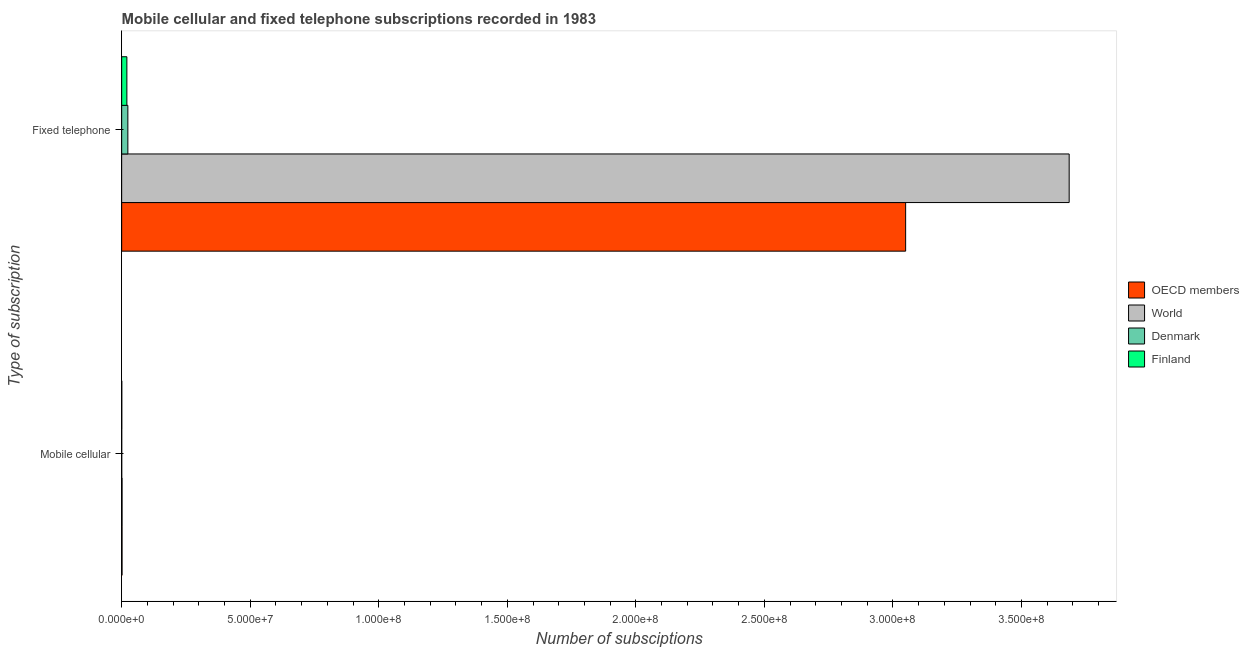What is the label of the 1st group of bars from the top?
Your answer should be very brief. Fixed telephone. What is the number of mobile cellular subscriptions in World?
Offer a very short reply. 1.49e+05. Across all countries, what is the maximum number of mobile cellular subscriptions?
Your answer should be compact. 1.49e+05. Across all countries, what is the minimum number of fixed telephone subscriptions?
Offer a very short reply. 2.02e+06. In which country was the number of mobile cellular subscriptions minimum?
Provide a succinct answer. Denmark. What is the total number of mobile cellular subscriptions in the graph?
Give a very brief answer. 3.52e+05. What is the difference between the number of fixed telephone subscriptions in OECD members and that in World?
Ensure brevity in your answer.  -6.36e+07. What is the difference between the number of fixed telephone subscriptions in World and the number of mobile cellular subscriptions in Finland?
Ensure brevity in your answer.  3.69e+08. What is the average number of mobile cellular subscriptions per country?
Your response must be concise. 8.81e+04. What is the difference between the number of mobile cellular subscriptions and number of fixed telephone subscriptions in Finland?
Provide a short and direct response. -1.98e+06. What is the ratio of the number of fixed telephone subscriptions in Denmark to that in OECD members?
Your answer should be compact. 0.01. What does the 1st bar from the top in Fixed telephone represents?
Keep it short and to the point. Finland. What does the 4th bar from the bottom in Mobile cellular represents?
Your response must be concise. Finland. Are all the bars in the graph horizontal?
Give a very brief answer. Yes. How many countries are there in the graph?
Offer a very short reply. 4. Does the graph contain any zero values?
Your response must be concise. No. Where does the legend appear in the graph?
Give a very brief answer. Center right. How are the legend labels stacked?
Ensure brevity in your answer.  Vertical. What is the title of the graph?
Provide a succinct answer. Mobile cellular and fixed telephone subscriptions recorded in 1983. What is the label or title of the X-axis?
Your answer should be very brief. Number of subsciptions. What is the label or title of the Y-axis?
Give a very brief answer. Type of subscription. What is the Number of subsciptions of OECD members in Mobile cellular?
Ensure brevity in your answer.  1.45e+05. What is the Number of subsciptions in World in Mobile cellular?
Offer a very short reply. 1.49e+05. What is the Number of subsciptions of Denmark in Mobile cellular?
Your response must be concise. 1.61e+04. What is the Number of subsciptions of Finland in Mobile cellular?
Offer a very short reply. 4.22e+04. What is the Number of subsciptions in OECD members in Fixed telephone?
Ensure brevity in your answer.  3.05e+08. What is the Number of subsciptions of World in Fixed telephone?
Ensure brevity in your answer.  3.69e+08. What is the Number of subsciptions of Denmark in Fixed telephone?
Your response must be concise. 2.40e+06. What is the Number of subsciptions in Finland in Fixed telephone?
Offer a terse response. 2.02e+06. Across all Type of subscription, what is the maximum Number of subsciptions of OECD members?
Ensure brevity in your answer.  3.05e+08. Across all Type of subscription, what is the maximum Number of subsciptions in World?
Ensure brevity in your answer.  3.69e+08. Across all Type of subscription, what is the maximum Number of subsciptions in Denmark?
Keep it short and to the point. 2.40e+06. Across all Type of subscription, what is the maximum Number of subsciptions in Finland?
Offer a very short reply. 2.02e+06. Across all Type of subscription, what is the minimum Number of subsciptions of OECD members?
Offer a terse response. 1.45e+05. Across all Type of subscription, what is the minimum Number of subsciptions in World?
Your response must be concise. 1.49e+05. Across all Type of subscription, what is the minimum Number of subsciptions of Denmark?
Ensure brevity in your answer.  1.61e+04. Across all Type of subscription, what is the minimum Number of subsciptions of Finland?
Your answer should be compact. 4.22e+04. What is the total Number of subsciptions of OECD members in the graph?
Your response must be concise. 3.05e+08. What is the total Number of subsciptions in World in the graph?
Your response must be concise. 3.69e+08. What is the total Number of subsciptions of Denmark in the graph?
Ensure brevity in your answer.  2.42e+06. What is the total Number of subsciptions in Finland in the graph?
Your answer should be very brief. 2.06e+06. What is the difference between the Number of subsciptions of OECD members in Mobile cellular and that in Fixed telephone?
Offer a very short reply. -3.05e+08. What is the difference between the Number of subsciptions of World in Mobile cellular and that in Fixed telephone?
Offer a terse response. -3.68e+08. What is the difference between the Number of subsciptions of Denmark in Mobile cellular and that in Fixed telephone?
Your response must be concise. -2.39e+06. What is the difference between the Number of subsciptions of Finland in Mobile cellular and that in Fixed telephone?
Your answer should be very brief. -1.98e+06. What is the difference between the Number of subsciptions of OECD members in Mobile cellular and the Number of subsciptions of World in Fixed telephone?
Provide a short and direct response. -3.68e+08. What is the difference between the Number of subsciptions in OECD members in Mobile cellular and the Number of subsciptions in Denmark in Fixed telephone?
Offer a very short reply. -2.26e+06. What is the difference between the Number of subsciptions in OECD members in Mobile cellular and the Number of subsciptions in Finland in Fixed telephone?
Give a very brief answer. -1.88e+06. What is the difference between the Number of subsciptions of World in Mobile cellular and the Number of subsciptions of Denmark in Fixed telephone?
Give a very brief answer. -2.25e+06. What is the difference between the Number of subsciptions of World in Mobile cellular and the Number of subsciptions of Finland in Fixed telephone?
Make the answer very short. -1.87e+06. What is the difference between the Number of subsciptions in Denmark in Mobile cellular and the Number of subsciptions in Finland in Fixed telephone?
Keep it short and to the point. -2.00e+06. What is the average Number of subsciptions in OECD members per Type of subscription?
Provide a short and direct response. 1.53e+08. What is the average Number of subsciptions in World per Type of subscription?
Provide a succinct answer. 1.84e+08. What is the average Number of subsciptions of Denmark per Type of subscription?
Make the answer very short. 1.21e+06. What is the average Number of subsciptions in Finland per Type of subscription?
Your answer should be compact. 1.03e+06. What is the difference between the Number of subsciptions of OECD members and Number of subsciptions of World in Mobile cellular?
Your answer should be compact. -3564. What is the difference between the Number of subsciptions of OECD members and Number of subsciptions of Denmark in Mobile cellular?
Offer a terse response. 1.29e+05. What is the difference between the Number of subsciptions in OECD members and Number of subsciptions in Finland in Mobile cellular?
Your answer should be compact. 1.03e+05. What is the difference between the Number of subsciptions in World and Number of subsciptions in Denmark in Mobile cellular?
Offer a terse response. 1.33e+05. What is the difference between the Number of subsciptions in World and Number of subsciptions in Finland in Mobile cellular?
Provide a short and direct response. 1.07e+05. What is the difference between the Number of subsciptions in Denmark and Number of subsciptions in Finland in Mobile cellular?
Offer a terse response. -2.61e+04. What is the difference between the Number of subsciptions in OECD members and Number of subsciptions in World in Fixed telephone?
Offer a very short reply. -6.36e+07. What is the difference between the Number of subsciptions of OECD members and Number of subsciptions of Denmark in Fixed telephone?
Keep it short and to the point. 3.03e+08. What is the difference between the Number of subsciptions in OECD members and Number of subsciptions in Finland in Fixed telephone?
Keep it short and to the point. 3.03e+08. What is the difference between the Number of subsciptions in World and Number of subsciptions in Denmark in Fixed telephone?
Offer a very short reply. 3.66e+08. What is the difference between the Number of subsciptions of World and Number of subsciptions of Finland in Fixed telephone?
Ensure brevity in your answer.  3.67e+08. What is the difference between the Number of subsciptions of Denmark and Number of subsciptions of Finland in Fixed telephone?
Give a very brief answer. 3.82e+05. What is the ratio of the Number of subsciptions of World in Mobile cellular to that in Fixed telephone?
Offer a terse response. 0. What is the ratio of the Number of subsciptions of Denmark in Mobile cellular to that in Fixed telephone?
Provide a succinct answer. 0.01. What is the ratio of the Number of subsciptions in Finland in Mobile cellular to that in Fixed telephone?
Provide a short and direct response. 0.02. What is the difference between the highest and the second highest Number of subsciptions of OECD members?
Offer a very short reply. 3.05e+08. What is the difference between the highest and the second highest Number of subsciptions in World?
Provide a short and direct response. 3.68e+08. What is the difference between the highest and the second highest Number of subsciptions of Denmark?
Your answer should be compact. 2.39e+06. What is the difference between the highest and the second highest Number of subsciptions of Finland?
Make the answer very short. 1.98e+06. What is the difference between the highest and the lowest Number of subsciptions in OECD members?
Give a very brief answer. 3.05e+08. What is the difference between the highest and the lowest Number of subsciptions in World?
Your answer should be compact. 3.68e+08. What is the difference between the highest and the lowest Number of subsciptions in Denmark?
Keep it short and to the point. 2.39e+06. What is the difference between the highest and the lowest Number of subsciptions of Finland?
Keep it short and to the point. 1.98e+06. 